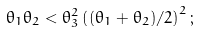Convert formula to latex. <formula><loc_0><loc_0><loc_500><loc_500>\theta _ { 1 } \theta _ { 2 } < \theta _ { 3 } ^ { 2 } \left ( ( \theta _ { 1 } + \theta _ { 2 } ) / 2 \right ) ^ { 2 } ;</formula> 